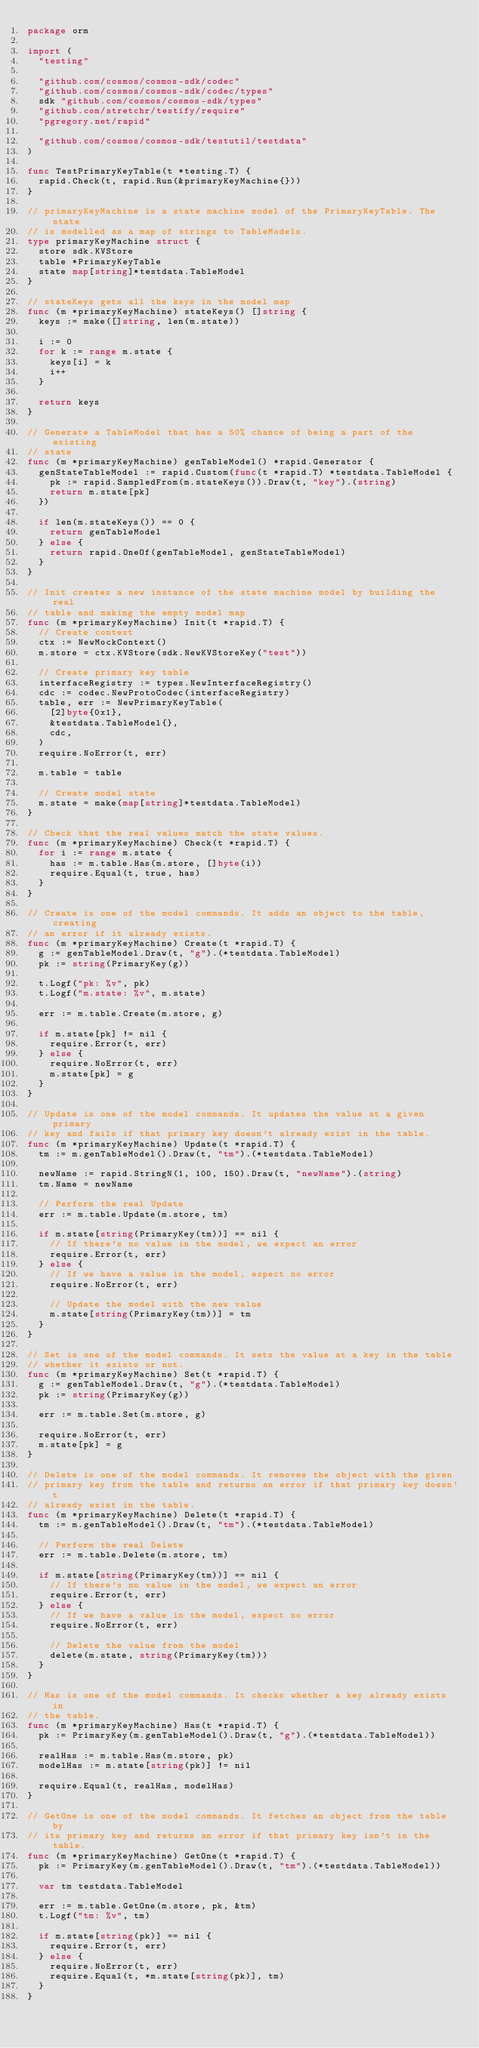<code> <loc_0><loc_0><loc_500><loc_500><_Go_>package orm

import (
	"testing"

	"github.com/cosmos/cosmos-sdk/codec"
	"github.com/cosmos/cosmos-sdk/codec/types"
	sdk "github.com/cosmos/cosmos-sdk/types"
	"github.com/stretchr/testify/require"
	"pgregory.net/rapid"

	"github.com/cosmos/cosmos-sdk/testutil/testdata"
)

func TestPrimaryKeyTable(t *testing.T) {
	rapid.Check(t, rapid.Run(&primaryKeyMachine{}))
}

// primaryKeyMachine is a state machine model of the PrimaryKeyTable. The state
// is modelled as a map of strings to TableModels.
type primaryKeyMachine struct {
	store sdk.KVStore
	table *PrimaryKeyTable
	state map[string]*testdata.TableModel
}

// stateKeys gets all the keys in the model map
func (m *primaryKeyMachine) stateKeys() []string {
	keys := make([]string, len(m.state))

	i := 0
	for k := range m.state {
		keys[i] = k
		i++
	}

	return keys
}

// Generate a TableModel that has a 50% chance of being a part of the existing
// state
func (m *primaryKeyMachine) genTableModel() *rapid.Generator {
	genStateTableModel := rapid.Custom(func(t *rapid.T) *testdata.TableModel {
		pk := rapid.SampledFrom(m.stateKeys()).Draw(t, "key").(string)
		return m.state[pk]
	})

	if len(m.stateKeys()) == 0 {
		return genTableModel
	} else {
		return rapid.OneOf(genTableModel, genStateTableModel)
	}
}

// Init creates a new instance of the state machine model by building the real
// table and making the empty model map
func (m *primaryKeyMachine) Init(t *rapid.T) {
	// Create context
	ctx := NewMockContext()
	m.store = ctx.KVStore(sdk.NewKVStoreKey("test"))

	// Create primary key table
	interfaceRegistry := types.NewInterfaceRegistry()
	cdc := codec.NewProtoCodec(interfaceRegistry)
	table, err := NewPrimaryKeyTable(
		[2]byte{0x1},
		&testdata.TableModel{},
		cdc,
	)
	require.NoError(t, err)

	m.table = table

	// Create model state
	m.state = make(map[string]*testdata.TableModel)
}

// Check that the real values match the state values.
func (m *primaryKeyMachine) Check(t *rapid.T) {
	for i := range m.state {
		has := m.table.Has(m.store, []byte(i))
		require.Equal(t, true, has)
	}
}

// Create is one of the model commands. It adds an object to the table, creating
// an error if it already exists.
func (m *primaryKeyMachine) Create(t *rapid.T) {
	g := genTableModel.Draw(t, "g").(*testdata.TableModel)
	pk := string(PrimaryKey(g))

	t.Logf("pk: %v", pk)
	t.Logf("m.state: %v", m.state)

	err := m.table.Create(m.store, g)

	if m.state[pk] != nil {
		require.Error(t, err)
	} else {
		require.NoError(t, err)
		m.state[pk] = g
	}
}

// Update is one of the model commands. It updates the value at a given primary
// key and fails if that primary key doesn't already exist in the table.
func (m *primaryKeyMachine) Update(t *rapid.T) {
	tm := m.genTableModel().Draw(t, "tm").(*testdata.TableModel)

	newName := rapid.StringN(1, 100, 150).Draw(t, "newName").(string)
	tm.Name = newName

	// Perform the real Update
	err := m.table.Update(m.store, tm)

	if m.state[string(PrimaryKey(tm))] == nil {
		// If there's no value in the model, we expect an error
		require.Error(t, err)
	} else {
		// If we have a value in the model, expect no error
		require.NoError(t, err)

		// Update the model with the new value
		m.state[string(PrimaryKey(tm))] = tm
	}
}

// Set is one of the model commands. It sets the value at a key in the table
// whether it exists or not.
func (m *primaryKeyMachine) Set(t *rapid.T) {
	g := genTableModel.Draw(t, "g").(*testdata.TableModel)
	pk := string(PrimaryKey(g))

	err := m.table.Set(m.store, g)

	require.NoError(t, err)
	m.state[pk] = g
}

// Delete is one of the model commands. It removes the object with the given
// primary key from the table and returns an error if that primary key doesn't
// already exist in the table.
func (m *primaryKeyMachine) Delete(t *rapid.T) {
	tm := m.genTableModel().Draw(t, "tm").(*testdata.TableModel)

	// Perform the real Delete
	err := m.table.Delete(m.store, tm)

	if m.state[string(PrimaryKey(tm))] == nil {
		// If there's no value in the model, we expect an error
		require.Error(t, err)
	} else {
		// If we have a value in the model, expect no error
		require.NoError(t, err)

		// Delete the value from the model
		delete(m.state, string(PrimaryKey(tm)))
	}
}

// Has is one of the model commands. It checks whether a key already exists in
// the table.
func (m *primaryKeyMachine) Has(t *rapid.T) {
	pk := PrimaryKey(m.genTableModel().Draw(t, "g").(*testdata.TableModel))

	realHas := m.table.Has(m.store, pk)
	modelHas := m.state[string(pk)] != nil

	require.Equal(t, realHas, modelHas)
}

// GetOne is one of the model commands. It fetches an object from the table by
// its primary key and returns an error if that primary key isn't in the table.
func (m *primaryKeyMachine) GetOne(t *rapid.T) {
	pk := PrimaryKey(m.genTableModel().Draw(t, "tm").(*testdata.TableModel))

	var tm testdata.TableModel

	err := m.table.GetOne(m.store, pk, &tm)
	t.Logf("tm: %v", tm)

	if m.state[string(pk)] == nil {
		require.Error(t, err)
	} else {
		require.NoError(t, err)
		require.Equal(t, *m.state[string(pk)], tm)
	}
}
</code> 